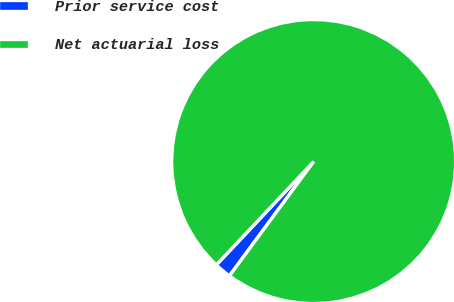Convert chart to OTSL. <chart><loc_0><loc_0><loc_500><loc_500><pie_chart><fcel>Prior service cost<fcel>Net actuarial loss<nl><fcel>1.92%<fcel>98.08%<nl></chart> 